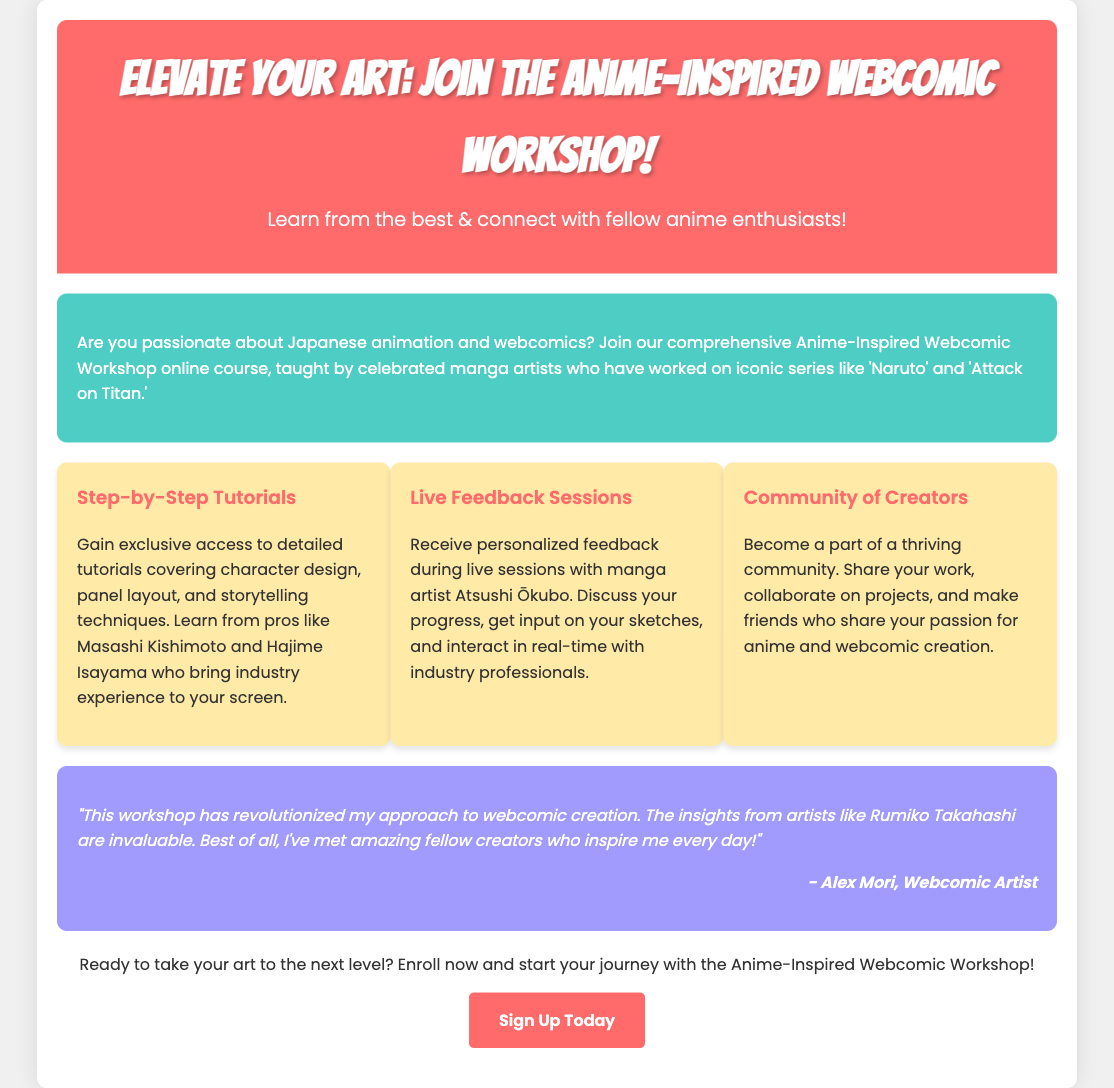What is the title of the workshop? The title of the workshop is clearly stated in the header of the document.
Answer: Anime-Inspired Webcomic Workshop Who teaches the workshop? The document mentions celebrated manga artists who are specifically identified as instructors.
Answer: Renowned manga artists What is the focus of the tutorials? The document lists specific aspects covered in the tutorials, highlighting the main focus.
Answer: Character design, panel layout, and storytelling techniques Who provides feedback during live sessions? The document identifies a specific manga artist that participates in the feedback sessions.
Answer: Atsushi Ōkubo What is the main benefit of joining the workshop? The document emphasizes connecting with fellow enthusiasts and improving art skills as key benefits.
Answer: Learn from the best & connect with fellow anime enthusiasts What kind of community is built in the workshop? The document describes the nature of the community participants join.
Answer: Thriving community How did Alex Mori describe the workshop? A testimonial in the document references the artist's opinion on the workshop's impact.
Answer: Revolutionized my approach What is the primary action encouraged at the end of the document? The document has a clear call to action encouraging a specific behavior.
Answer: Enroll now What type of course is this? The document describes the format and style of the course being offered.
Answer: Online course 